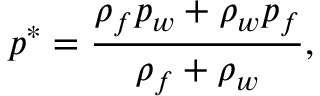<formula> <loc_0><loc_0><loc_500><loc_500>p ^ { * } = \frac { \rho _ { f } p _ { w } + \rho _ { w } p _ { f } } { \rho _ { f } + \rho _ { w } } ,</formula> 